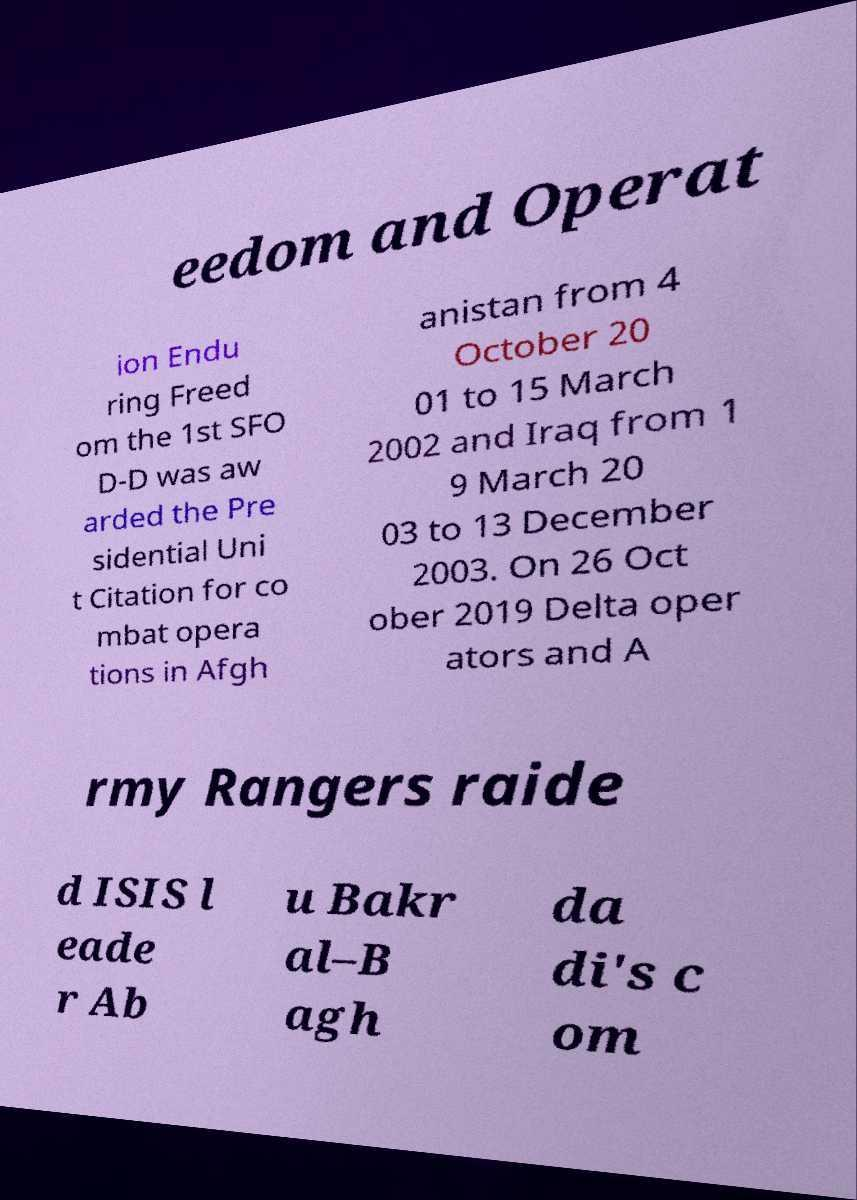Please read and relay the text visible in this image. What does it say? eedom and Operat ion Endu ring Freed om the 1st SFO D-D was aw arded the Pre sidential Uni t Citation for co mbat opera tions in Afgh anistan from 4 October 20 01 to 15 March 2002 and Iraq from 1 9 March 20 03 to 13 December 2003. On 26 Oct ober 2019 Delta oper ators and A rmy Rangers raide d ISIS l eade r Ab u Bakr al–B agh da di's c om 